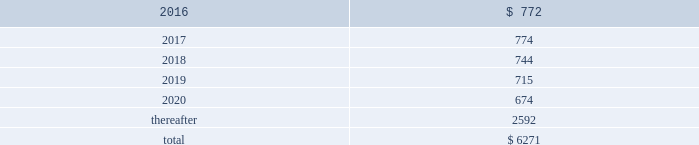Table of contents the company uses some custom components that are not commonly used by its competitors , and new products introduced by the company often utilize custom components available from only one source .
When a component or product uses new technologies , initial capacity constraints may exist until the suppliers 2019 yields have matured or manufacturing capacity has increased .
If the company 2019s supply of components for a new or existing product were delayed or constrained , or if an outsourcing partner delayed shipments of completed products to the company , the company 2019s financial condition and operating results could be materially adversely affected .
The company 2019s business and financial performance could also be materially adversely affected depending on the time required to obtain sufficient quantities from the original source , or to identify and obtain sufficient quantities from an alternative source .
Continued availability of these components at acceptable prices , or at all , may be affected if those suppliers concentrated on the production of common components instead of components customized to meet the company 2019s requirements .
The company has entered into agreements for the supply of many components ; however , there can be no guarantee that the company will be able to extend or renew these agreements on similar terms , or at all .
Therefore , the company remains subject to significant risks of supply shortages and price increases that could materially adversely affect its financial condition and operating results .
Substantially all of the company 2019s hardware products are manufactured by outsourcing partners that are located primarily in asia .
A significant concentration of this manufacturing is currently performed by a small number of outsourcing partners , often in single locations .
Certain of these outsourcing partners are the sole- sourced suppliers of components and manufacturers for many of the company 2019s products .
Although the company works closely with its outsourcing partners on manufacturing schedules , the company 2019s operating results could be adversely affected if its outsourcing partners were unable to meet their production commitments .
The company 2019s purchase commitments typically cover its requirements for periods up to 150 days .
Other off-balance sheet commitments operating leases the company leases various equipment and facilities , including retail space , under noncancelable operating lease arrangements .
The company does not currently utilize any other off-balance sheet financing arrangements .
The major facility leases are typically for terms not exceeding 10 years and generally contain multi-year renewal options .
As of september 26 , 2015 , the company had a total of 463 retail stores .
Leases for retail space are for terms ranging from five to 20 years , the majority of which are for 10 years , and often contain multi-year renewal options .
As of september 26 , 2015 , the company 2019s total future minimum lease payments under noncancelable operating leases were $ 6.3 billion , of which $ 3.6 billion related to leases for retail space .
Rent expense under all operating leases , including both cancelable and noncancelable leases , was $ 794 million , $ 717 million and $ 645 million in 2015 , 2014 and 2013 , respectively .
Future minimum lease payments under noncancelable operating leases having remaining terms in excess of one year as of september 26 , 2015 , are as follows ( in millions ) : .
Other commitments the company utilizes several outsourcing partners to manufacture sub-assemblies for the company 2019s products and to perform final assembly and testing of finished products .
These outsourcing partners acquire components and build product based on demand information supplied by the company , which typically covers periods up to 150 days .
The company also obtains individual components for its products from a wide variety of individual suppliers .
Consistent with industry practice , the company acquires components through a combination of purchase orders , supplier contracts and open orders based on projected demand information .
Where appropriate , the purchases are applied to inventory component prepayments that are outstanding with the respective supplier .
As of september 26 , 2015 , the company had outstanding off-balance sheet third-party manufacturing commitments and component purchase commitments of $ 29.5 billion .
Apple inc .
| 2015 form 10-k | 65 .
What percentage of future minimum lease payments under noncancelable operating leases are due after 2020? 
Computations: (2592 / 6271)
Answer: 0.41333. 